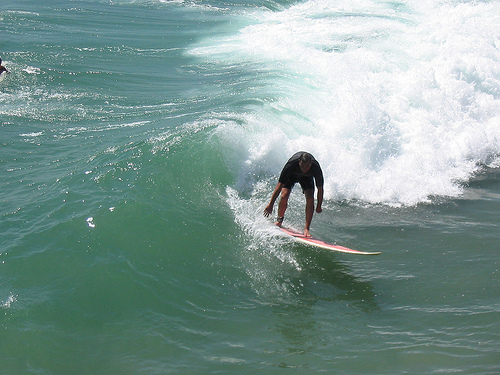Please provide a short description for this region: [0.52, 0.55, 0.75, 0.65]. This region contains a large white and red surfboard navigating through the water, a key element in the surfing action. 